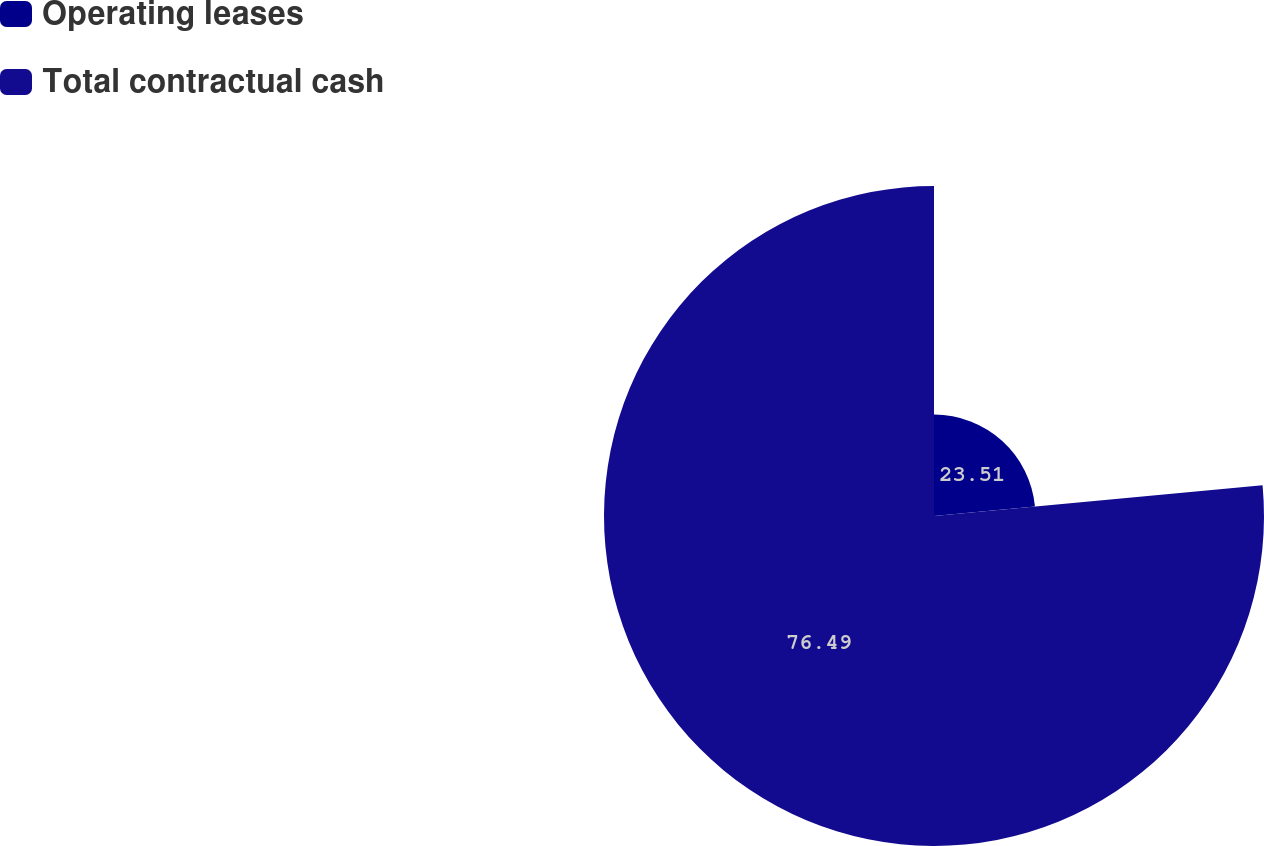<chart> <loc_0><loc_0><loc_500><loc_500><pie_chart><fcel>Operating leases<fcel>Total contractual cash<nl><fcel>23.51%<fcel>76.49%<nl></chart> 